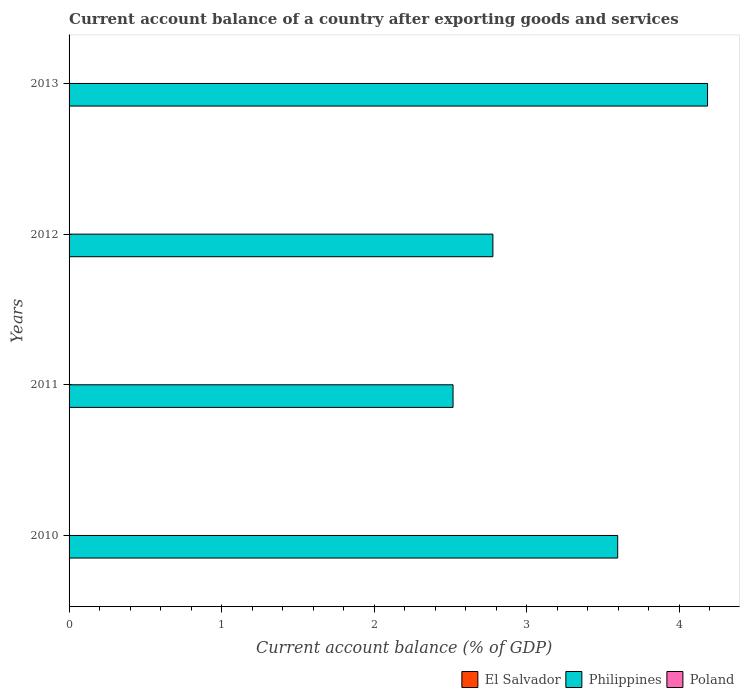Are the number of bars per tick equal to the number of legend labels?
Provide a succinct answer. No. In how many cases, is the number of bars for a given year not equal to the number of legend labels?
Keep it short and to the point. 4. Across all years, what is the maximum account balance in Philippines?
Provide a succinct answer. 4.19. Across all years, what is the minimum account balance in Poland?
Ensure brevity in your answer.  0. In which year was the account balance in Philippines maximum?
Ensure brevity in your answer.  2013. What is the total account balance in Poland in the graph?
Provide a short and direct response. 0. What is the difference between the account balance in Philippines in 2010 and that in 2012?
Your response must be concise. 0.82. What is the difference between the account balance in El Salvador in 2011 and the account balance in Philippines in 2013?
Offer a terse response. -4.19. What is the average account balance in Poland per year?
Offer a terse response. 0. In how many years, is the account balance in El Salvador greater than 1.4 %?
Make the answer very short. 0. What is the ratio of the account balance in Philippines in 2011 to that in 2012?
Ensure brevity in your answer.  0.91. What is the difference between the highest and the second highest account balance in Philippines?
Offer a terse response. 0.59. What is the difference between the highest and the lowest account balance in Philippines?
Your answer should be very brief. 1.67. In how many years, is the account balance in El Salvador greater than the average account balance in El Salvador taken over all years?
Make the answer very short. 0. Is it the case that in every year, the sum of the account balance in Philippines and account balance in Poland is greater than the account balance in El Salvador?
Ensure brevity in your answer.  Yes. What is the difference between two consecutive major ticks on the X-axis?
Provide a succinct answer. 1. Does the graph contain any zero values?
Make the answer very short. Yes. How are the legend labels stacked?
Make the answer very short. Horizontal. What is the title of the graph?
Make the answer very short. Current account balance of a country after exporting goods and services. Does "Arab World" appear as one of the legend labels in the graph?
Ensure brevity in your answer.  No. What is the label or title of the X-axis?
Provide a succinct answer. Current account balance (% of GDP). What is the label or title of the Y-axis?
Provide a succinct answer. Years. What is the Current account balance (% of GDP) in El Salvador in 2010?
Provide a short and direct response. 0. What is the Current account balance (% of GDP) in Philippines in 2010?
Make the answer very short. 3.6. What is the Current account balance (% of GDP) in Poland in 2010?
Offer a very short reply. 0. What is the Current account balance (% of GDP) in Philippines in 2011?
Your response must be concise. 2.52. What is the Current account balance (% of GDP) in Poland in 2011?
Your answer should be very brief. 0. What is the Current account balance (% of GDP) in El Salvador in 2012?
Provide a succinct answer. 0. What is the Current account balance (% of GDP) of Philippines in 2012?
Provide a succinct answer. 2.78. What is the Current account balance (% of GDP) in El Salvador in 2013?
Your answer should be compact. 0. What is the Current account balance (% of GDP) of Philippines in 2013?
Give a very brief answer. 4.19. What is the Current account balance (% of GDP) of Poland in 2013?
Provide a short and direct response. 0. Across all years, what is the maximum Current account balance (% of GDP) of Philippines?
Offer a terse response. 4.19. Across all years, what is the minimum Current account balance (% of GDP) of Philippines?
Your response must be concise. 2.52. What is the total Current account balance (% of GDP) in El Salvador in the graph?
Keep it short and to the point. 0. What is the total Current account balance (% of GDP) in Philippines in the graph?
Provide a succinct answer. 13.08. What is the difference between the Current account balance (% of GDP) in Philippines in 2010 and that in 2011?
Provide a succinct answer. 1.08. What is the difference between the Current account balance (% of GDP) of Philippines in 2010 and that in 2012?
Your answer should be compact. 0.82. What is the difference between the Current account balance (% of GDP) in Philippines in 2010 and that in 2013?
Make the answer very short. -0.59. What is the difference between the Current account balance (% of GDP) in Philippines in 2011 and that in 2012?
Your response must be concise. -0.26. What is the difference between the Current account balance (% of GDP) of Philippines in 2011 and that in 2013?
Your answer should be compact. -1.67. What is the difference between the Current account balance (% of GDP) in Philippines in 2012 and that in 2013?
Provide a succinct answer. -1.41. What is the average Current account balance (% of GDP) in Philippines per year?
Offer a terse response. 3.27. What is the ratio of the Current account balance (% of GDP) of Philippines in 2010 to that in 2011?
Offer a terse response. 1.43. What is the ratio of the Current account balance (% of GDP) of Philippines in 2010 to that in 2012?
Ensure brevity in your answer.  1.29. What is the ratio of the Current account balance (% of GDP) of Philippines in 2010 to that in 2013?
Make the answer very short. 0.86. What is the ratio of the Current account balance (% of GDP) in Philippines in 2011 to that in 2012?
Your response must be concise. 0.91. What is the ratio of the Current account balance (% of GDP) in Philippines in 2011 to that in 2013?
Provide a succinct answer. 0.6. What is the ratio of the Current account balance (% of GDP) of Philippines in 2012 to that in 2013?
Your response must be concise. 0.66. What is the difference between the highest and the second highest Current account balance (% of GDP) in Philippines?
Make the answer very short. 0.59. What is the difference between the highest and the lowest Current account balance (% of GDP) of Philippines?
Your answer should be very brief. 1.67. 